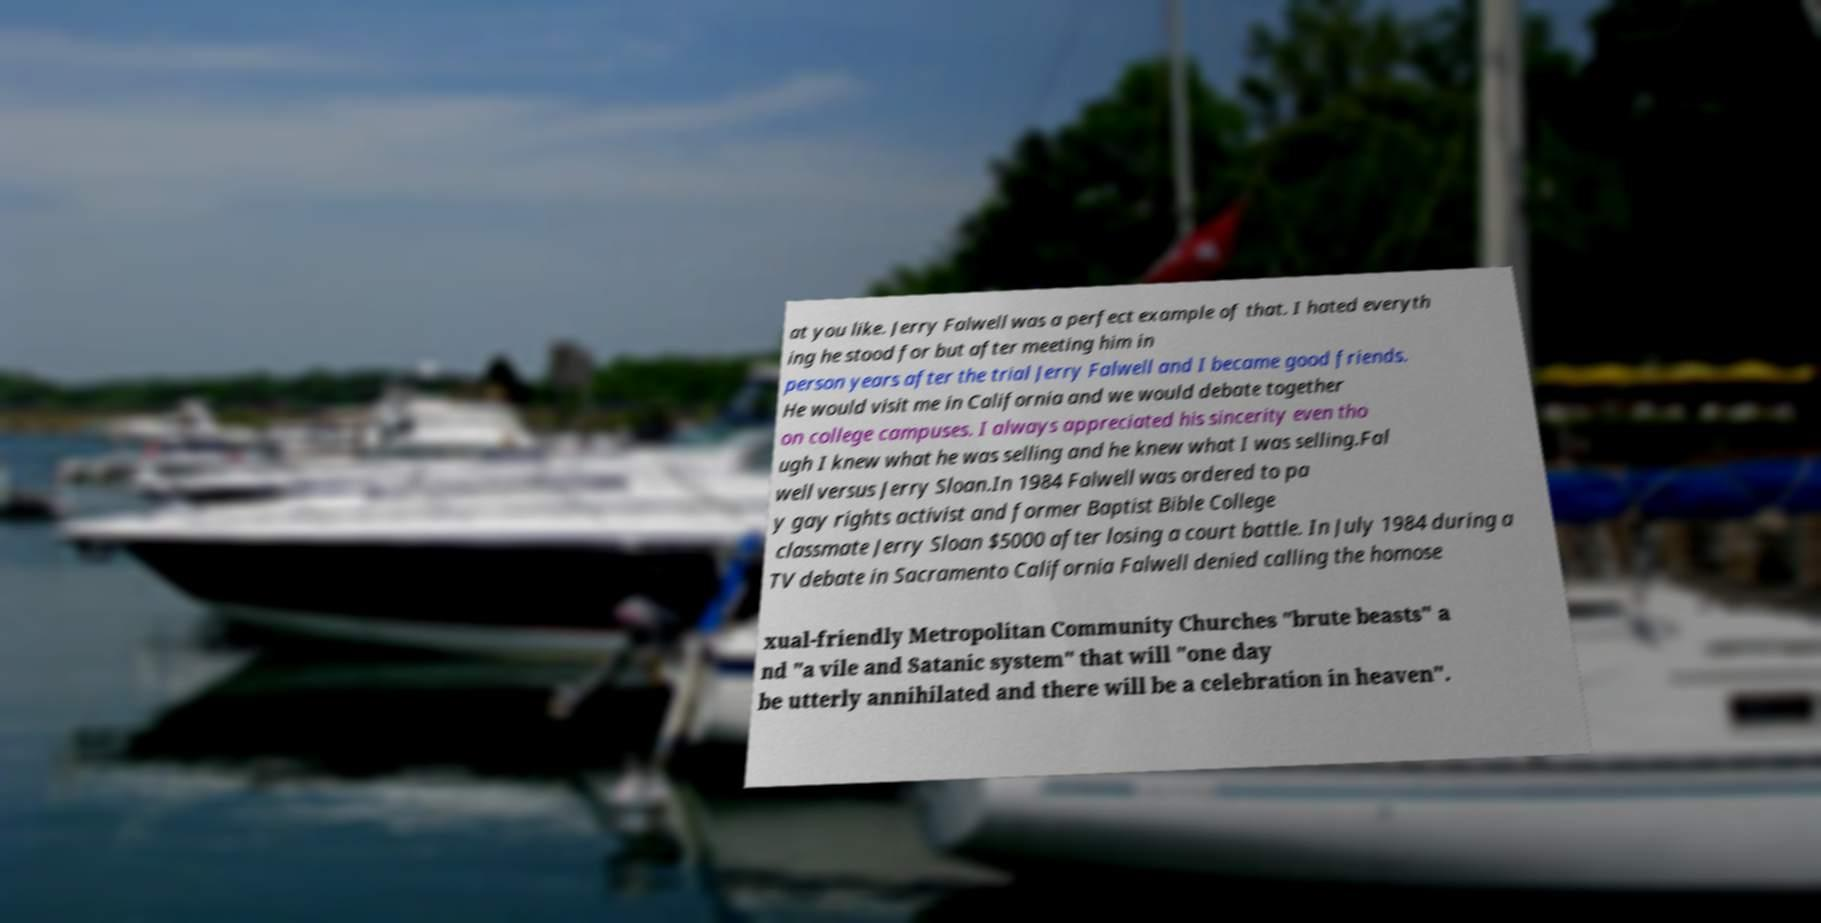Please identify and transcribe the text found in this image. at you like. Jerry Falwell was a perfect example of that. I hated everyth ing he stood for but after meeting him in person years after the trial Jerry Falwell and I became good friends. He would visit me in California and we would debate together on college campuses. I always appreciated his sincerity even tho ugh I knew what he was selling and he knew what I was selling.Fal well versus Jerry Sloan.In 1984 Falwell was ordered to pa y gay rights activist and former Baptist Bible College classmate Jerry Sloan $5000 after losing a court battle. In July 1984 during a TV debate in Sacramento California Falwell denied calling the homose xual-friendly Metropolitan Community Churches "brute beasts" a nd "a vile and Satanic system" that will "one day be utterly annihilated and there will be a celebration in heaven". 